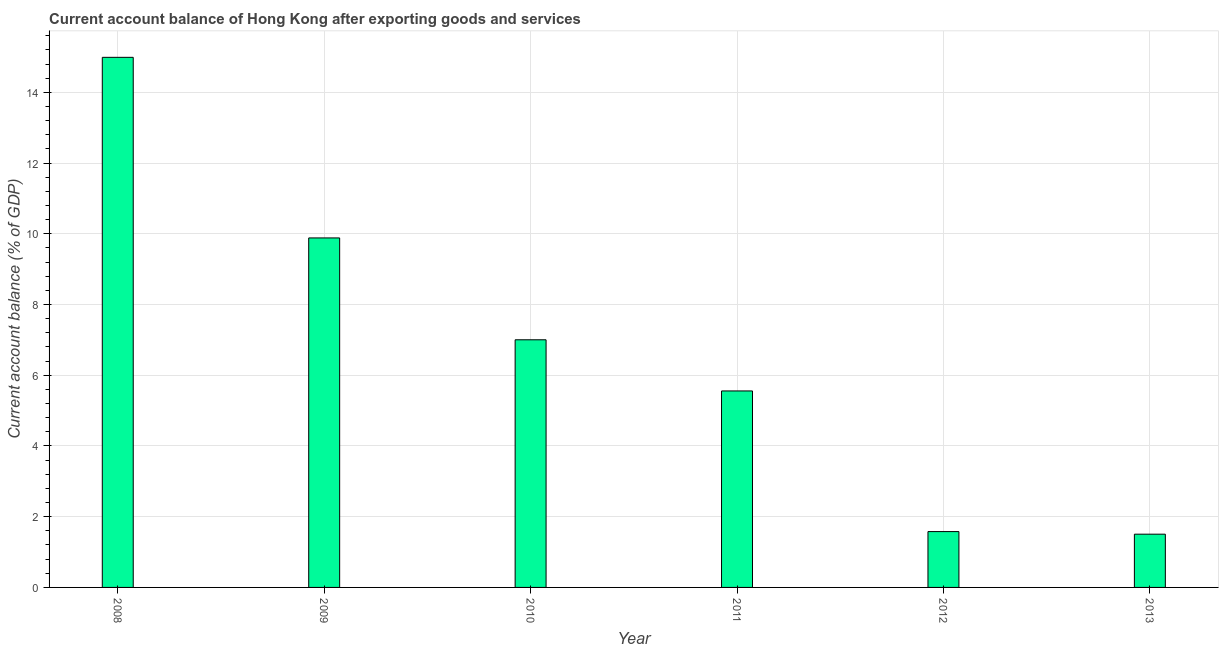Does the graph contain grids?
Your response must be concise. Yes. What is the title of the graph?
Provide a succinct answer. Current account balance of Hong Kong after exporting goods and services. What is the label or title of the Y-axis?
Keep it short and to the point. Current account balance (% of GDP). What is the current account balance in 2008?
Ensure brevity in your answer.  14.99. Across all years, what is the maximum current account balance?
Make the answer very short. 14.99. Across all years, what is the minimum current account balance?
Give a very brief answer. 1.51. In which year was the current account balance minimum?
Your answer should be compact. 2013. What is the sum of the current account balance?
Your answer should be very brief. 40.52. What is the difference between the current account balance in 2010 and 2013?
Offer a terse response. 5.5. What is the average current account balance per year?
Your answer should be compact. 6.75. What is the median current account balance?
Offer a terse response. 6.28. Do a majority of the years between 2010 and 2013 (inclusive) have current account balance greater than 7.6 %?
Offer a terse response. No. What is the ratio of the current account balance in 2008 to that in 2013?
Provide a succinct answer. 9.95. What is the difference between the highest and the second highest current account balance?
Offer a terse response. 5.11. Is the sum of the current account balance in 2009 and 2011 greater than the maximum current account balance across all years?
Your response must be concise. Yes. What is the difference between the highest and the lowest current account balance?
Provide a short and direct response. 13.48. How many bars are there?
Provide a succinct answer. 6. Are all the bars in the graph horizontal?
Offer a very short reply. No. Are the values on the major ticks of Y-axis written in scientific E-notation?
Your response must be concise. No. What is the Current account balance (% of GDP) in 2008?
Your answer should be compact. 14.99. What is the Current account balance (% of GDP) in 2009?
Provide a short and direct response. 9.88. What is the Current account balance (% of GDP) of 2010?
Keep it short and to the point. 7. What is the Current account balance (% of GDP) in 2011?
Offer a very short reply. 5.56. What is the Current account balance (% of GDP) in 2012?
Your answer should be very brief. 1.58. What is the Current account balance (% of GDP) in 2013?
Provide a short and direct response. 1.51. What is the difference between the Current account balance (% of GDP) in 2008 and 2009?
Provide a succinct answer. 5.11. What is the difference between the Current account balance (% of GDP) in 2008 and 2010?
Offer a very short reply. 7.99. What is the difference between the Current account balance (% of GDP) in 2008 and 2011?
Provide a short and direct response. 9.43. What is the difference between the Current account balance (% of GDP) in 2008 and 2012?
Offer a terse response. 13.41. What is the difference between the Current account balance (% of GDP) in 2008 and 2013?
Offer a terse response. 13.48. What is the difference between the Current account balance (% of GDP) in 2009 and 2010?
Provide a succinct answer. 2.88. What is the difference between the Current account balance (% of GDP) in 2009 and 2011?
Provide a succinct answer. 4.33. What is the difference between the Current account balance (% of GDP) in 2009 and 2012?
Provide a short and direct response. 8.3. What is the difference between the Current account balance (% of GDP) in 2009 and 2013?
Make the answer very short. 8.38. What is the difference between the Current account balance (% of GDP) in 2010 and 2011?
Make the answer very short. 1.45. What is the difference between the Current account balance (% of GDP) in 2010 and 2012?
Give a very brief answer. 5.42. What is the difference between the Current account balance (% of GDP) in 2010 and 2013?
Make the answer very short. 5.5. What is the difference between the Current account balance (% of GDP) in 2011 and 2012?
Provide a short and direct response. 3.98. What is the difference between the Current account balance (% of GDP) in 2011 and 2013?
Provide a succinct answer. 4.05. What is the difference between the Current account balance (% of GDP) in 2012 and 2013?
Provide a succinct answer. 0.07. What is the ratio of the Current account balance (% of GDP) in 2008 to that in 2009?
Provide a short and direct response. 1.52. What is the ratio of the Current account balance (% of GDP) in 2008 to that in 2010?
Provide a succinct answer. 2.14. What is the ratio of the Current account balance (% of GDP) in 2008 to that in 2011?
Your answer should be very brief. 2.7. What is the ratio of the Current account balance (% of GDP) in 2008 to that in 2012?
Make the answer very short. 9.49. What is the ratio of the Current account balance (% of GDP) in 2008 to that in 2013?
Provide a succinct answer. 9.95. What is the ratio of the Current account balance (% of GDP) in 2009 to that in 2010?
Provide a succinct answer. 1.41. What is the ratio of the Current account balance (% of GDP) in 2009 to that in 2011?
Keep it short and to the point. 1.78. What is the ratio of the Current account balance (% of GDP) in 2009 to that in 2012?
Provide a short and direct response. 6.26. What is the ratio of the Current account balance (% of GDP) in 2009 to that in 2013?
Ensure brevity in your answer.  6.56. What is the ratio of the Current account balance (% of GDP) in 2010 to that in 2011?
Offer a terse response. 1.26. What is the ratio of the Current account balance (% of GDP) in 2010 to that in 2012?
Give a very brief answer. 4.43. What is the ratio of the Current account balance (% of GDP) in 2010 to that in 2013?
Your answer should be very brief. 4.65. What is the ratio of the Current account balance (% of GDP) in 2011 to that in 2012?
Make the answer very short. 3.52. What is the ratio of the Current account balance (% of GDP) in 2011 to that in 2013?
Make the answer very short. 3.69. What is the ratio of the Current account balance (% of GDP) in 2012 to that in 2013?
Ensure brevity in your answer.  1.05. 